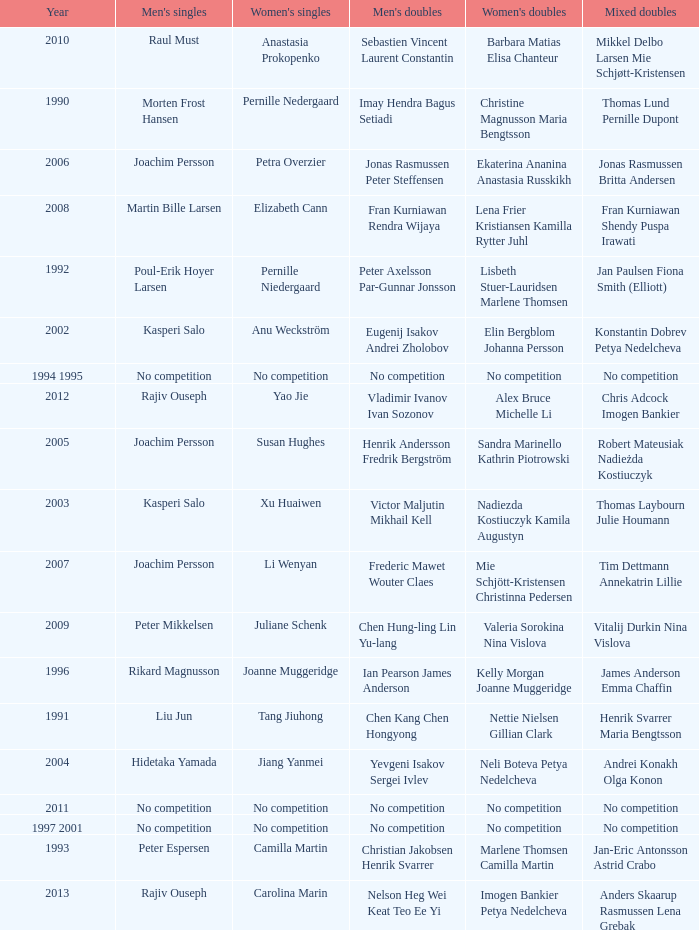What year did Carolina Marin win the Women's singles? 2013.0. 